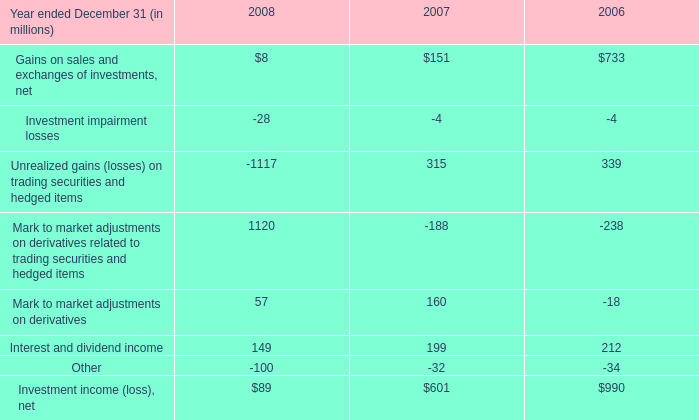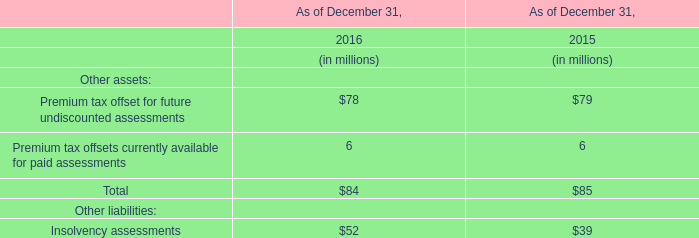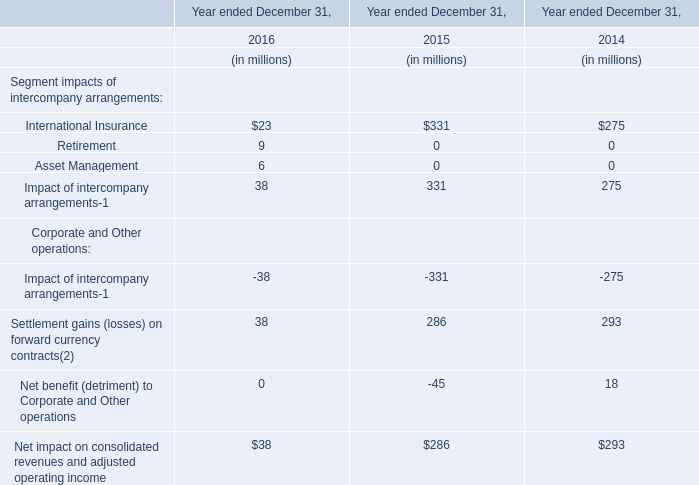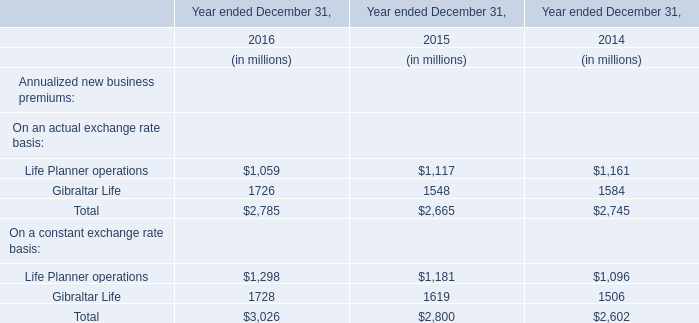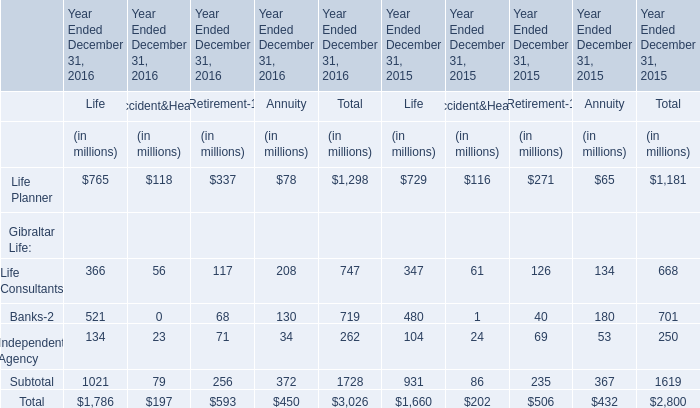what was the percent of our investment in clearwire compared to other investors 
Computations: (1.05 / 3.2)
Answer: 0.32812. 